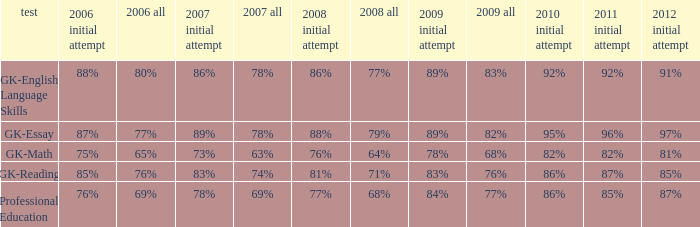What is the percentage for first time in 2012 when it was 82% for all in 2009? 97%. 